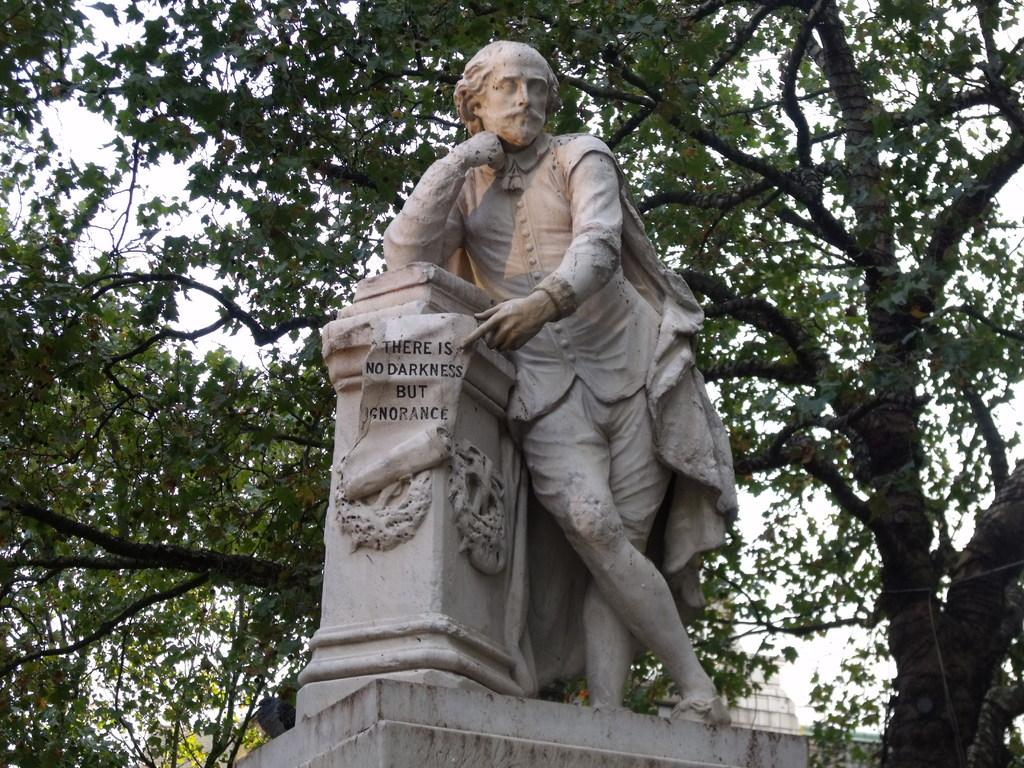What is the main subject in the image? There is a statue in the image. What can be seen on the statue? There is text on the statue. What type of environment is visible in the background of the image? There are trees in the background of the image. How many keys are hanging from the statue in the image? There are no keys present in the image; the statue has text on it. What are the girls doing in the image? There are no girls present in the image; it features a statue with text and trees in the background. 